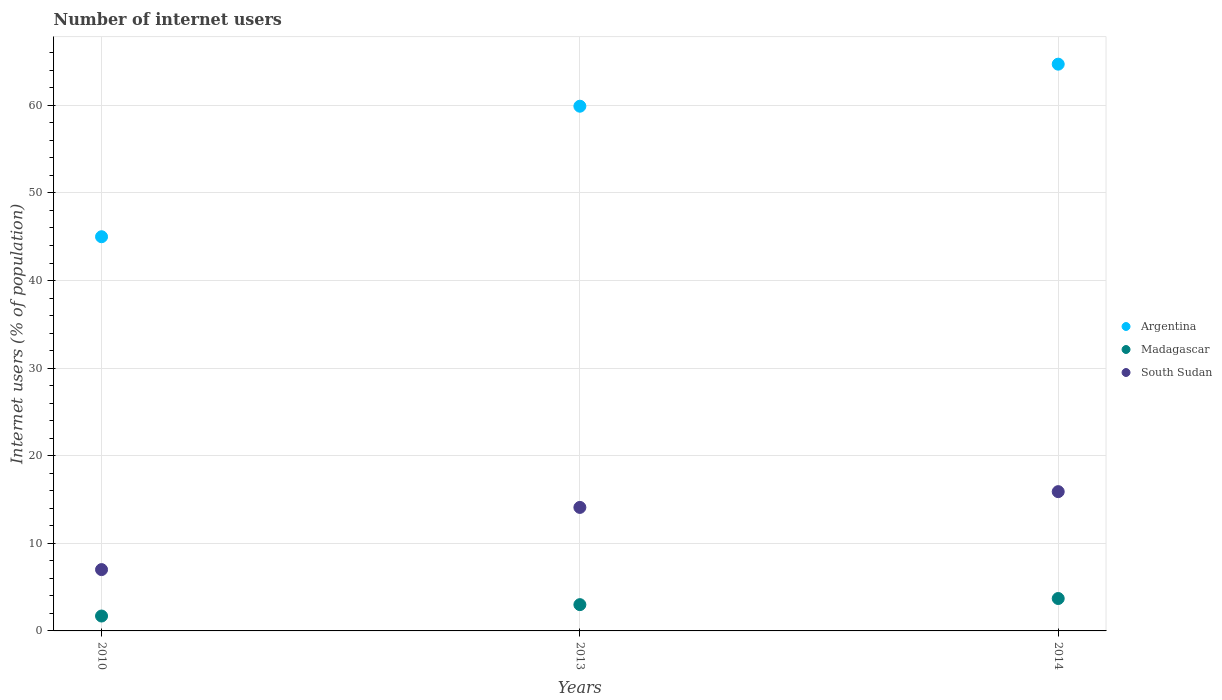Is the number of dotlines equal to the number of legend labels?
Provide a short and direct response. Yes. What is the number of internet users in South Sudan in 2010?
Offer a very short reply. 7. Across all years, what is the maximum number of internet users in Madagascar?
Provide a short and direct response. 3.7. Across all years, what is the minimum number of internet users in Argentina?
Make the answer very short. 45. In which year was the number of internet users in South Sudan maximum?
Make the answer very short. 2014. In which year was the number of internet users in South Sudan minimum?
Your answer should be compact. 2010. What is the total number of internet users in South Sudan in the graph?
Offer a very short reply. 37. What is the difference between the number of internet users in Madagascar in 2013 and the number of internet users in Argentina in 2014?
Your answer should be compact. -61.7. What is the average number of internet users in Madagascar per year?
Your response must be concise. 2.8. In the year 2010, what is the difference between the number of internet users in South Sudan and number of internet users in Argentina?
Your response must be concise. -38. In how many years, is the number of internet users in Madagascar greater than 40 %?
Offer a very short reply. 0. What is the ratio of the number of internet users in Madagascar in 2010 to that in 2014?
Your answer should be very brief. 0.46. Is the difference between the number of internet users in South Sudan in 2010 and 2014 greater than the difference between the number of internet users in Argentina in 2010 and 2014?
Your answer should be very brief. Yes. What is the difference between the highest and the second highest number of internet users in Argentina?
Offer a very short reply. 4.8. Is it the case that in every year, the sum of the number of internet users in Argentina and number of internet users in Madagascar  is greater than the number of internet users in South Sudan?
Provide a succinct answer. Yes. Does the number of internet users in Argentina monotonically increase over the years?
Provide a short and direct response. Yes. Is the number of internet users in Madagascar strictly greater than the number of internet users in Argentina over the years?
Offer a very short reply. No. Does the graph contain any zero values?
Keep it short and to the point. No. Where does the legend appear in the graph?
Give a very brief answer. Center right. How many legend labels are there?
Offer a very short reply. 3. What is the title of the graph?
Ensure brevity in your answer.  Number of internet users. What is the label or title of the Y-axis?
Your answer should be very brief. Internet users (% of population). What is the Internet users (% of population) in Madagascar in 2010?
Your answer should be compact. 1.7. What is the Internet users (% of population) in Argentina in 2013?
Your response must be concise. 59.9. What is the Internet users (% of population) of Madagascar in 2013?
Give a very brief answer. 3. What is the Internet users (% of population) in South Sudan in 2013?
Make the answer very short. 14.1. What is the Internet users (% of population) in Argentina in 2014?
Provide a short and direct response. 64.7. What is the Internet users (% of population) of Madagascar in 2014?
Give a very brief answer. 3.7. Across all years, what is the maximum Internet users (% of population) of Argentina?
Your answer should be compact. 64.7. Across all years, what is the maximum Internet users (% of population) of Madagascar?
Keep it short and to the point. 3.7. Across all years, what is the minimum Internet users (% of population) of Argentina?
Your answer should be very brief. 45. Across all years, what is the minimum Internet users (% of population) of Madagascar?
Your answer should be compact. 1.7. Across all years, what is the minimum Internet users (% of population) in South Sudan?
Your answer should be compact. 7. What is the total Internet users (% of population) of Argentina in the graph?
Your answer should be compact. 169.6. What is the total Internet users (% of population) in Madagascar in the graph?
Your answer should be compact. 8.4. What is the total Internet users (% of population) of South Sudan in the graph?
Provide a succinct answer. 37. What is the difference between the Internet users (% of population) of Argentina in 2010 and that in 2013?
Provide a succinct answer. -14.9. What is the difference between the Internet users (% of population) of Madagascar in 2010 and that in 2013?
Keep it short and to the point. -1.3. What is the difference between the Internet users (% of population) in Argentina in 2010 and that in 2014?
Keep it short and to the point. -19.7. What is the difference between the Internet users (% of population) of Argentina in 2013 and that in 2014?
Your answer should be very brief. -4.8. What is the difference between the Internet users (% of population) of Madagascar in 2013 and that in 2014?
Offer a terse response. -0.7. What is the difference between the Internet users (% of population) in South Sudan in 2013 and that in 2014?
Offer a very short reply. -1.8. What is the difference between the Internet users (% of population) in Argentina in 2010 and the Internet users (% of population) in Madagascar in 2013?
Offer a terse response. 42. What is the difference between the Internet users (% of population) in Argentina in 2010 and the Internet users (% of population) in South Sudan in 2013?
Offer a very short reply. 30.9. What is the difference between the Internet users (% of population) in Madagascar in 2010 and the Internet users (% of population) in South Sudan in 2013?
Make the answer very short. -12.4. What is the difference between the Internet users (% of population) in Argentina in 2010 and the Internet users (% of population) in Madagascar in 2014?
Your answer should be compact. 41.3. What is the difference between the Internet users (% of population) in Argentina in 2010 and the Internet users (% of population) in South Sudan in 2014?
Provide a short and direct response. 29.1. What is the difference between the Internet users (% of population) in Madagascar in 2010 and the Internet users (% of population) in South Sudan in 2014?
Give a very brief answer. -14.2. What is the difference between the Internet users (% of population) of Argentina in 2013 and the Internet users (% of population) of Madagascar in 2014?
Provide a short and direct response. 56.2. What is the difference between the Internet users (% of population) in Argentina in 2013 and the Internet users (% of population) in South Sudan in 2014?
Your answer should be very brief. 44. What is the difference between the Internet users (% of population) of Madagascar in 2013 and the Internet users (% of population) of South Sudan in 2014?
Your answer should be compact. -12.9. What is the average Internet users (% of population) in Argentina per year?
Provide a short and direct response. 56.53. What is the average Internet users (% of population) of Madagascar per year?
Offer a very short reply. 2.8. What is the average Internet users (% of population) in South Sudan per year?
Keep it short and to the point. 12.33. In the year 2010, what is the difference between the Internet users (% of population) of Argentina and Internet users (% of population) of Madagascar?
Give a very brief answer. 43.3. In the year 2010, what is the difference between the Internet users (% of population) of Argentina and Internet users (% of population) of South Sudan?
Provide a short and direct response. 38. In the year 2010, what is the difference between the Internet users (% of population) in Madagascar and Internet users (% of population) in South Sudan?
Offer a terse response. -5.3. In the year 2013, what is the difference between the Internet users (% of population) in Argentina and Internet users (% of population) in Madagascar?
Ensure brevity in your answer.  56.9. In the year 2013, what is the difference between the Internet users (% of population) in Argentina and Internet users (% of population) in South Sudan?
Offer a terse response. 45.8. In the year 2013, what is the difference between the Internet users (% of population) in Madagascar and Internet users (% of population) in South Sudan?
Your answer should be compact. -11.1. In the year 2014, what is the difference between the Internet users (% of population) in Argentina and Internet users (% of population) in Madagascar?
Give a very brief answer. 61. In the year 2014, what is the difference between the Internet users (% of population) in Argentina and Internet users (% of population) in South Sudan?
Your response must be concise. 48.8. In the year 2014, what is the difference between the Internet users (% of population) of Madagascar and Internet users (% of population) of South Sudan?
Offer a very short reply. -12.2. What is the ratio of the Internet users (% of population) of Argentina in 2010 to that in 2013?
Provide a succinct answer. 0.75. What is the ratio of the Internet users (% of population) of Madagascar in 2010 to that in 2013?
Provide a short and direct response. 0.57. What is the ratio of the Internet users (% of population) in South Sudan in 2010 to that in 2013?
Offer a very short reply. 0.5. What is the ratio of the Internet users (% of population) of Argentina in 2010 to that in 2014?
Your answer should be compact. 0.7. What is the ratio of the Internet users (% of population) in Madagascar in 2010 to that in 2014?
Your answer should be compact. 0.46. What is the ratio of the Internet users (% of population) in South Sudan in 2010 to that in 2014?
Keep it short and to the point. 0.44. What is the ratio of the Internet users (% of population) in Argentina in 2013 to that in 2014?
Your response must be concise. 0.93. What is the ratio of the Internet users (% of population) in Madagascar in 2013 to that in 2014?
Your response must be concise. 0.81. What is the ratio of the Internet users (% of population) of South Sudan in 2013 to that in 2014?
Provide a succinct answer. 0.89. What is the difference between the highest and the second highest Internet users (% of population) of Argentina?
Keep it short and to the point. 4.8. What is the difference between the highest and the lowest Internet users (% of population) of Argentina?
Offer a terse response. 19.7. 